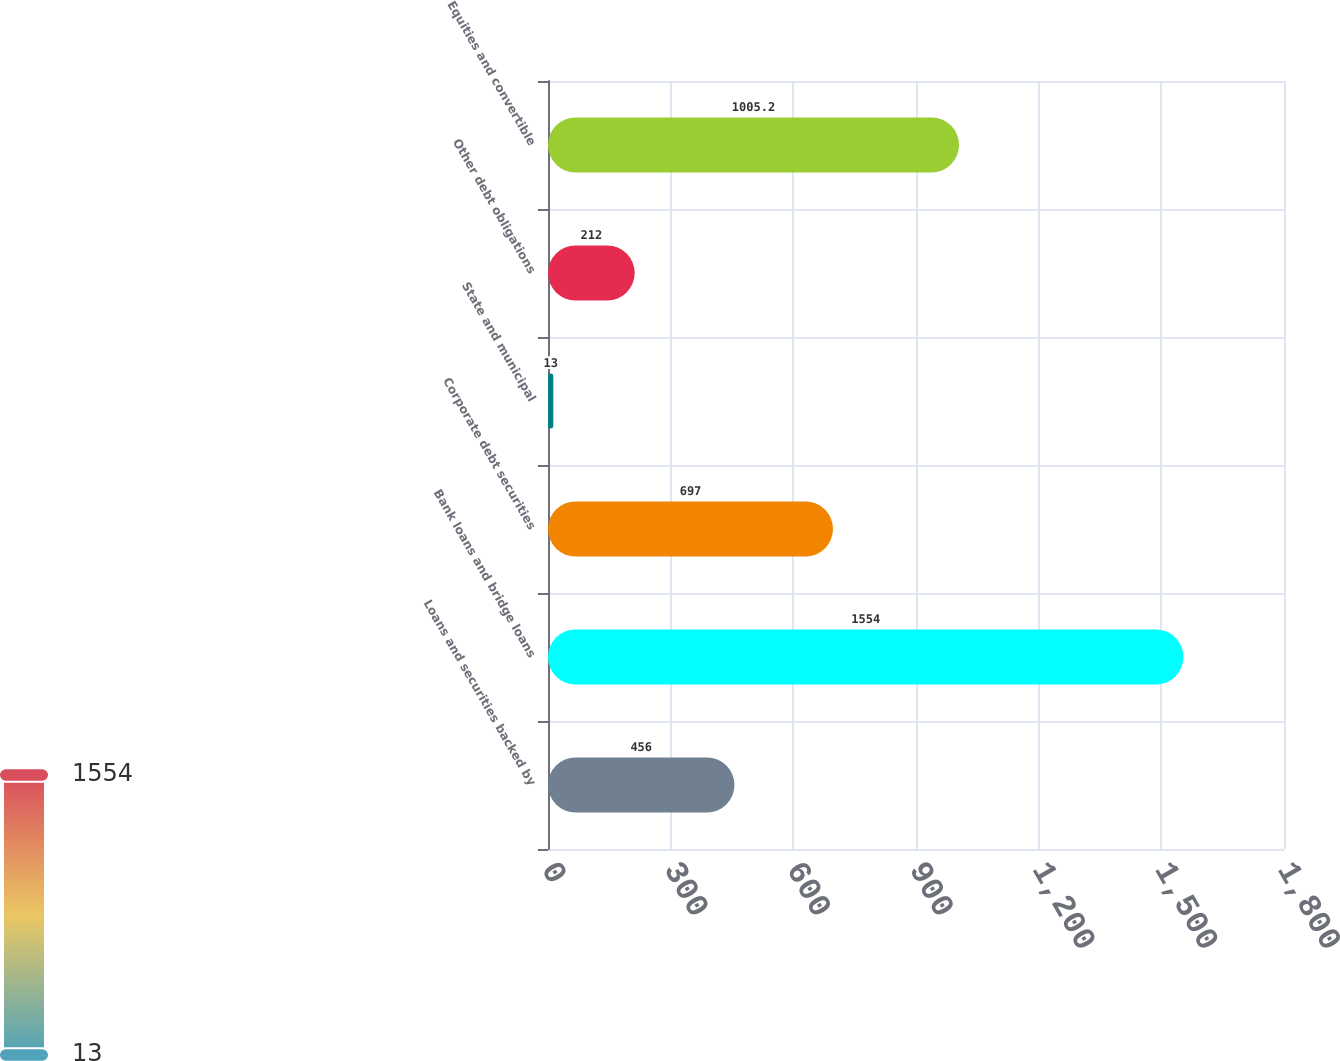<chart> <loc_0><loc_0><loc_500><loc_500><bar_chart><fcel>Loans and securities backed by<fcel>Bank loans and bridge loans<fcel>Corporate debt securities<fcel>State and municipal<fcel>Other debt obligations<fcel>Equities and convertible<nl><fcel>456<fcel>1554<fcel>697<fcel>13<fcel>212<fcel>1005.2<nl></chart> 